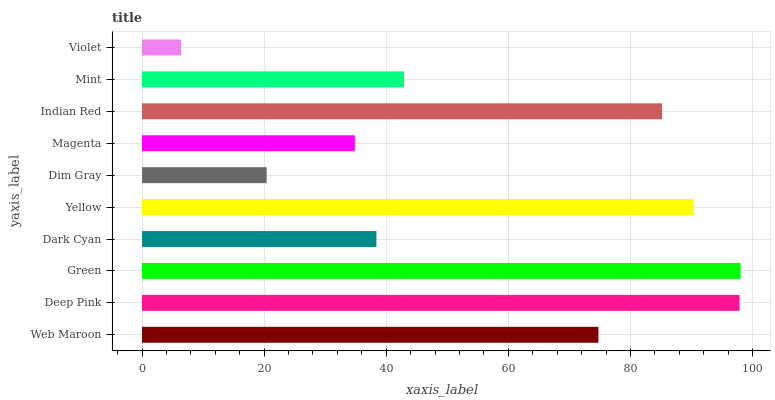Is Violet the minimum?
Answer yes or no. Yes. Is Green the maximum?
Answer yes or no. Yes. Is Deep Pink the minimum?
Answer yes or no. No. Is Deep Pink the maximum?
Answer yes or no. No. Is Deep Pink greater than Web Maroon?
Answer yes or no. Yes. Is Web Maroon less than Deep Pink?
Answer yes or no. Yes. Is Web Maroon greater than Deep Pink?
Answer yes or no. No. Is Deep Pink less than Web Maroon?
Answer yes or no. No. Is Web Maroon the high median?
Answer yes or no. Yes. Is Mint the low median?
Answer yes or no. Yes. Is Mint the high median?
Answer yes or no. No. Is Magenta the low median?
Answer yes or no. No. 